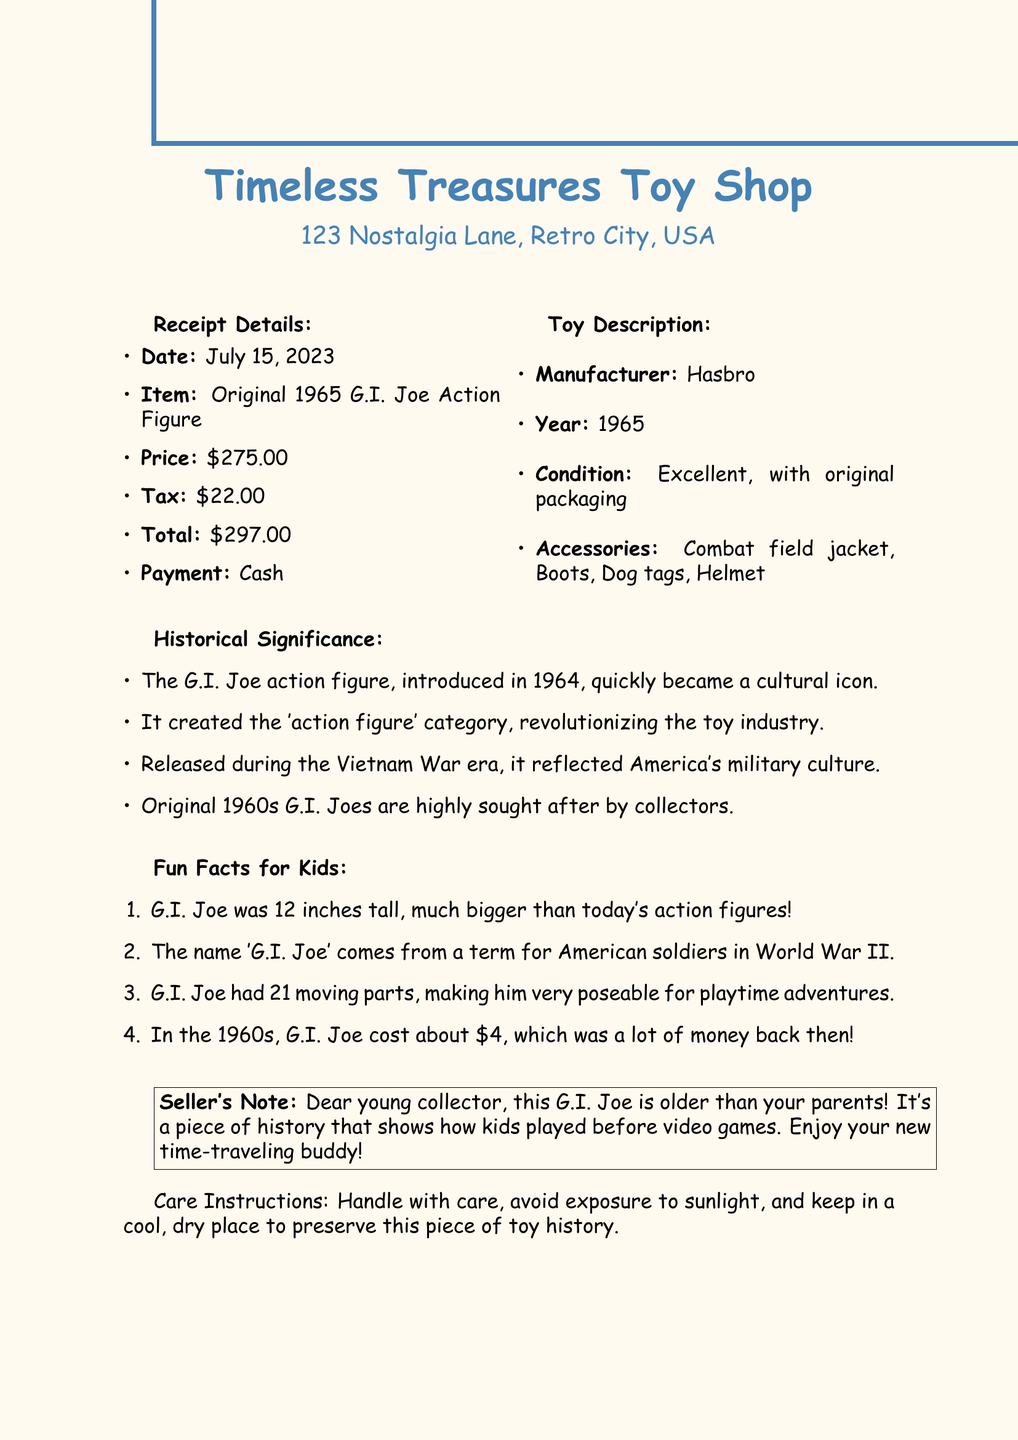What is the name of the store? The store name is provided in the document as the place where the purchase was made, which is Timeless Treasures Toy Shop.
Answer: Timeless Treasures Toy Shop What was the date of the purchase? The purchase date is explicitly mentioned in the receipt details section of the document, which states July 15, 2023.
Answer: July 15, 2023 How much was the item sold for? The price of the item is listed in the document before tax, specifically as $275.00.
Answer: $275.00 What is the year of production for the G.I. Joe action figure? The document states that the action figure was produced in 1965, indicating its production year.
Answer: 1965 Why is the G.I. Joe considered a cultural icon? The document explains that it became a cultural icon quickly after its introduction in 1964 and had significant impact on the toy industry.
Answer: It revolutionized the toy industry What are some accessories included with the toy? The document lists the accessories, including a combat field jacket, boots, dog tags, and a helmet.
Answer: Combat field jacket, Boots, Dog tags, Helmet What was the original price of G.I. Joe in the 1960s? The document mentions that G.I. Joe cost about $4 in the 1960s.
Answer: $4 What kind of payment method was used? The payment method is noted in the receipt details section, which details that cash was the payment method for the purchase.
Answer: Cash What care instructions are provided for the toy? The document includes care instructions stating to handle with care and avoid exposure to sunlight among other precautions.
Answer: Handle with care, avoid exposure to sunlight 